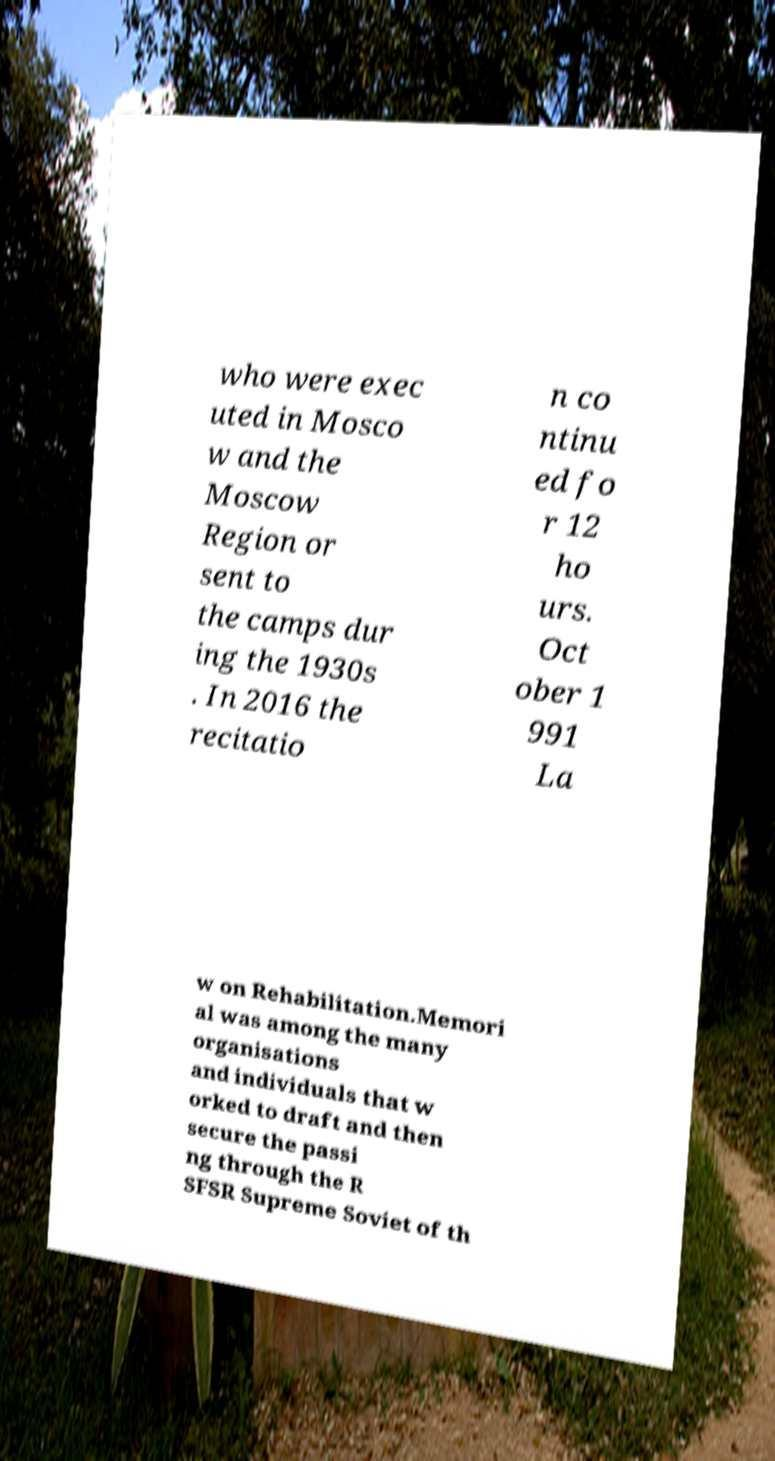I need the written content from this picture converted into text. Can you do that? who were exec uted in Mosco w and the Moscow Region or sent to the camps dur ing the 1930s . In 2016 the recitatio n co ntinu ed fo r 12 ho urs. Oct ober 1 991 La w on Rehabilitation.Memori al was among the many organisations and individuals that w orked to draft and then secure the passi ng through the R SFSR Supreme Soviet of th 